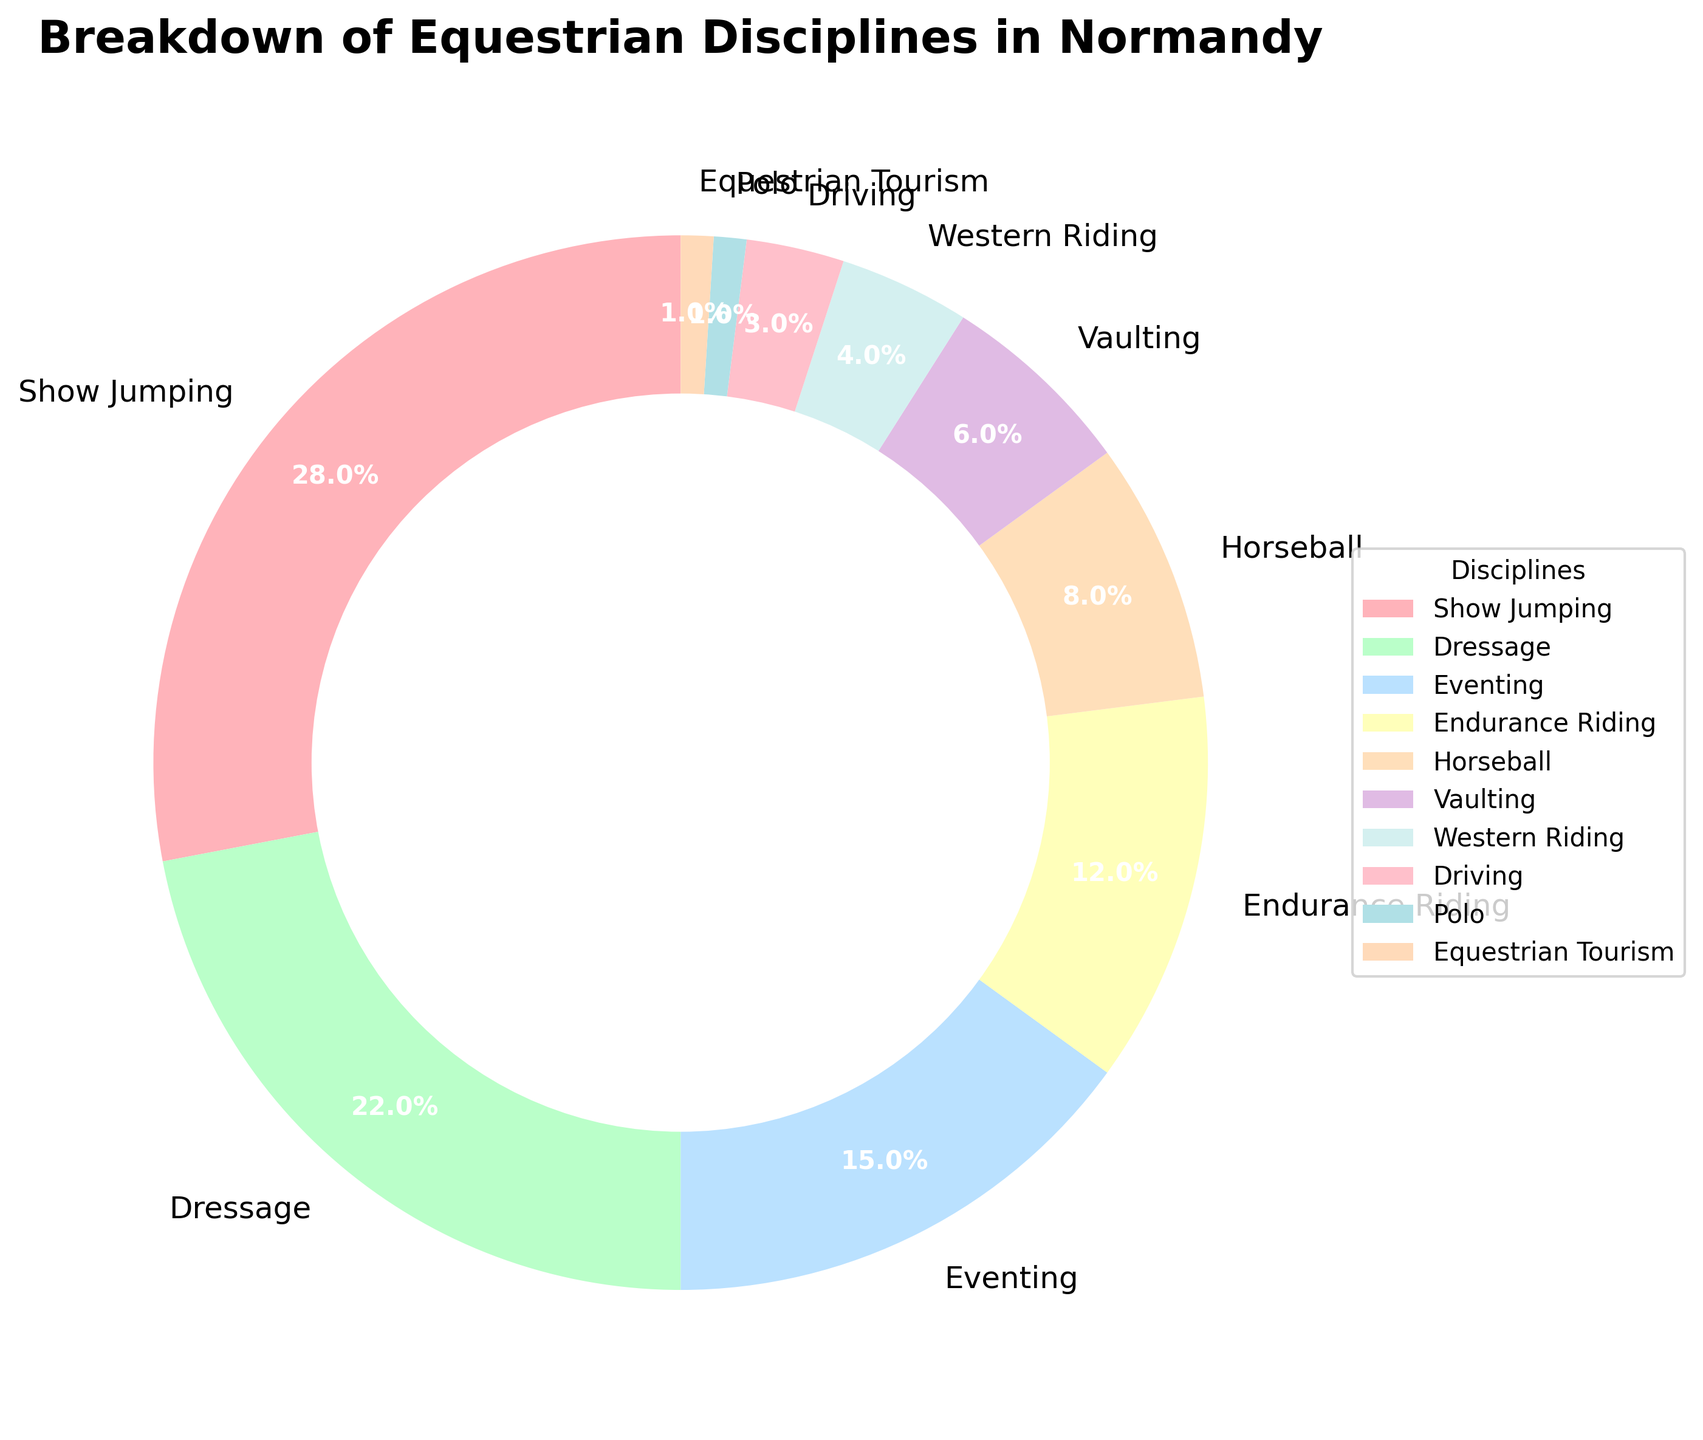What percentage of equestrian disciplines does Show Jumping represent? Show Jumping represents 28% of the breakdown. This is shown by the wedge labeled "Show Jumping" on the pie chart.
Answer: 28% Which discipline is more popular, Dressage or Eventing, and by how much? Dressage is more popular than Eventing. Dressage has a percentage of 22% while Eventing has a percentage of 15%, so Dressage is more popular by 22% - 15% = 7%.
Answer: Dressage by 7% For which disciplines do the combined percentages equal 20%? Combined percentages of 20% can be found by summing up the percentages of Vaulting (6%) and Horseball (8%) which totals to 14%. We then add the percentage of Driving (3%) to get 17%. Add the percentage of Polo (1%) to get 18%, and finally the percentage of Equestrian Tourism (1%) to get a total of 19%. Thus, the closest combined percentage of 20% is the sum of Horseball, Vaulting, and Driving which gives 8% + 6% + 4% = 18%. Add Western Riding's 4% gives exactly 20%.
Answer: Vaulting, Horseball, Western Riding Which discipline has the least representation and what is its percentage? The discipline with the least representation is Polo, as indicated by the smallest wedge on the pie chart. It represents 1% of the breakdown.
Answer: Polo, 1% What is the difference in percentage between Endurance Riding and Horseball? To find the difference, subtract Horseball's percentage (8%) from Endurance Riding's percentage (12%). This gives a difference of 12% - 8% = 4%.
Answer: 4% Combining Show Jumping, Dressage, and Eventing, what percentage do they account for? Adding the percentages of Show Jumping (28%), Dressage (22%), and Eventing (15%) gives a total: 28% + 22% + 15% = 65%.
Answer: 65% Is there any discipline that exactly represents 5% of the breakdown? According to the pie chart, none of the disciplines represent exactly 5% of the breakdown. The closest values are 4% for Western Riding and 6% for Vaulting.
Answer: No How does the popularity of Western Riding and Driving compare? Western Riding has a higher percentage compared to Driving. Western Riding stands at 4%, while Driving is at 3%.
Answer: Western Riding > Driving 